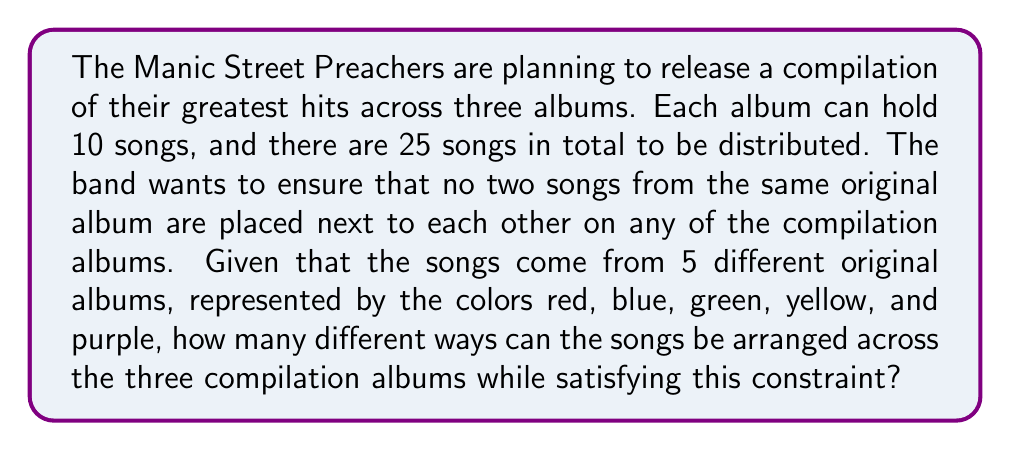Solve this math problem. To solve this problem, we can model it as a graph coloring problem where each song is a vertex and edges connect songs from the same original album. We need to color the vertices (assign songs to compilation albums) such that no two adjacent vertices have the same color.

Let's approach this step-by-step:

1) First, we need to determine the chromatic number of our graph. Since we have 5 original albums, the maximum number of adjacent vertices is 4 (a song can be from the same album as at most 4 other songs). Therefore, the chromatic number is 5.

2) We have 3 compilation albums, which means we're effectively using 3 colors to color our graph. This is less than the chromatic number, which ensures we can always find a valid coloring.

3) Now, we need to calculate the number of ways to distribute 25 songs across 3 albums of 10 songs each, with 5 songs left over. This is a combination problem:

   $$\binom{25}{10} \cdot \binom{15}{10} \cdot \binom{5}{5} = \frac{25!}{10!15!} \cdot \frac{15!}{10!5!} \cdot 1$$

4) However, this counts all possible distributions, including those that violate our constraint. We need to apply the Principle of Inclusion-Exclusion to exclude invalid arrangements.

5) The probability of a random arrangement satisfying our constraint is equal to the number of proper 5-colorings of a path of length 25, divided by $5^{25}$ (total number of colorings).

6) The number of proper 5-colorings of a path of length n is given by the recurrence relation:
   $$a_n = 5a_{n-1} - 5a_{n-2} + 5a_{n-3} - a_{n-4}$$
   with initial conditions $a_1 = 5, a_2 = 20, a_3 = 75, a_4 = 275$.

7) Using this recurrence relation, we can calculate that the number of proper 5-colorings for a path of length 25 is approximately $1.2306 \times 10^{17}$.

8) Therefore, the probability of a valid arrangement is:
   $$\frac{1.2306 \times 10^{17}}{5^{25}} \approx 0.1578$$

9) Finally, we multiply our total number of distributions by this probability to get the number of valid arrangements.
Answer: The number of different ways the songs can be arranged across the three compilation albums while satisfying the constraint is approximately:

$$\binom{25}{10} \cdot \binom{15}{10} \cdot \binom{5}{5} \cdot 0.1578 \approx 1.0736 \times 10^{10}$$

or about 10,736,000,000 different valid arrangements. 